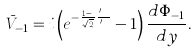Convert formula to latex. <formula><loc_0><loc_0><loc_500><loc_500>\bar { V } _ { - 1 } = i \left ( e ^ { - \frac { 1 - i } { \sqrt { 2 } } \frac { X ^ { \prime } } { \delta ^ { \prime } } } - 1 \right ) \frac { d \Phi _ { - 1 } } { d y } .</formula> 